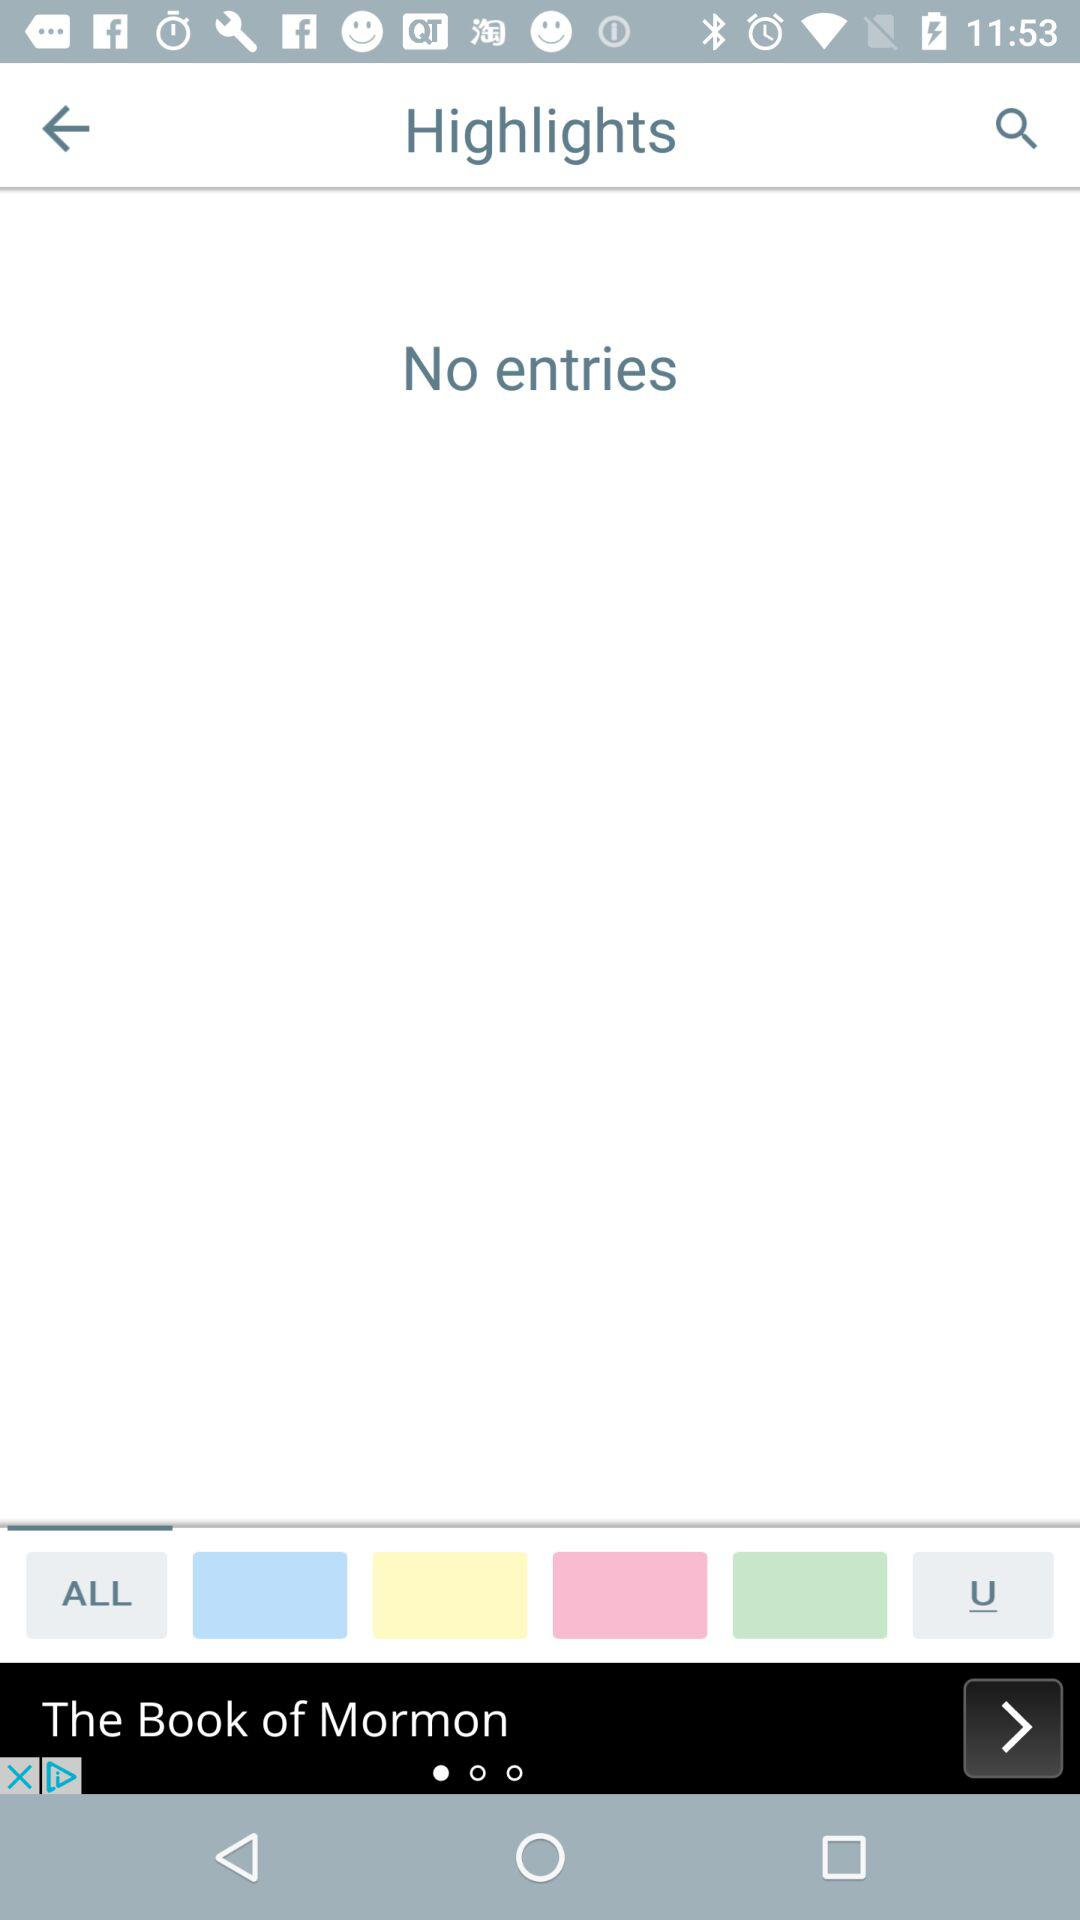Are there any entries? There are no entries. 